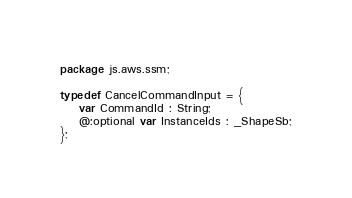<code> <loc_0><loc_0><loc_500><loc_500><_Haxe_>package js.aws.ssm;

typedef CancelCommandInput = {
    var CommandId : String;
    @:optional var InstanceIds : _ShapeSb;
};
</code> 